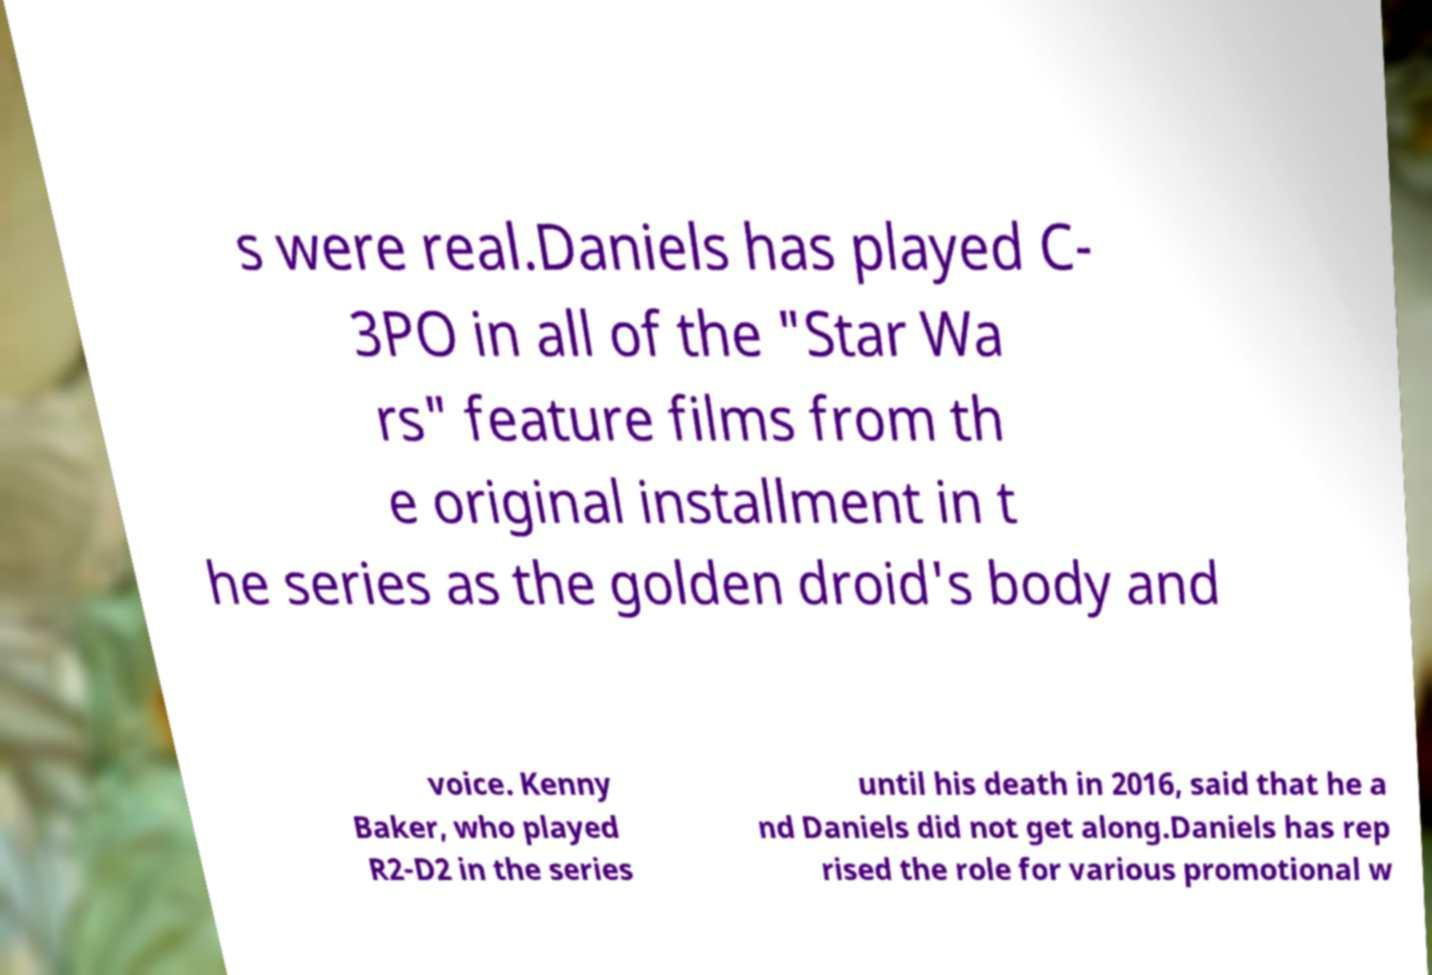Please read and relay the text visible in this image. What does it say? s were real.Daniels has played C- 3PO in all of the "Star Wa rs" feature films from th e original installment in t he series as the golden droid's body and voice. Kenny Baker, who played R2-D2 in the series until his death in 2016, said that he a nd Daniels did not get along.Daniels has rep rised the role for various promotional w 